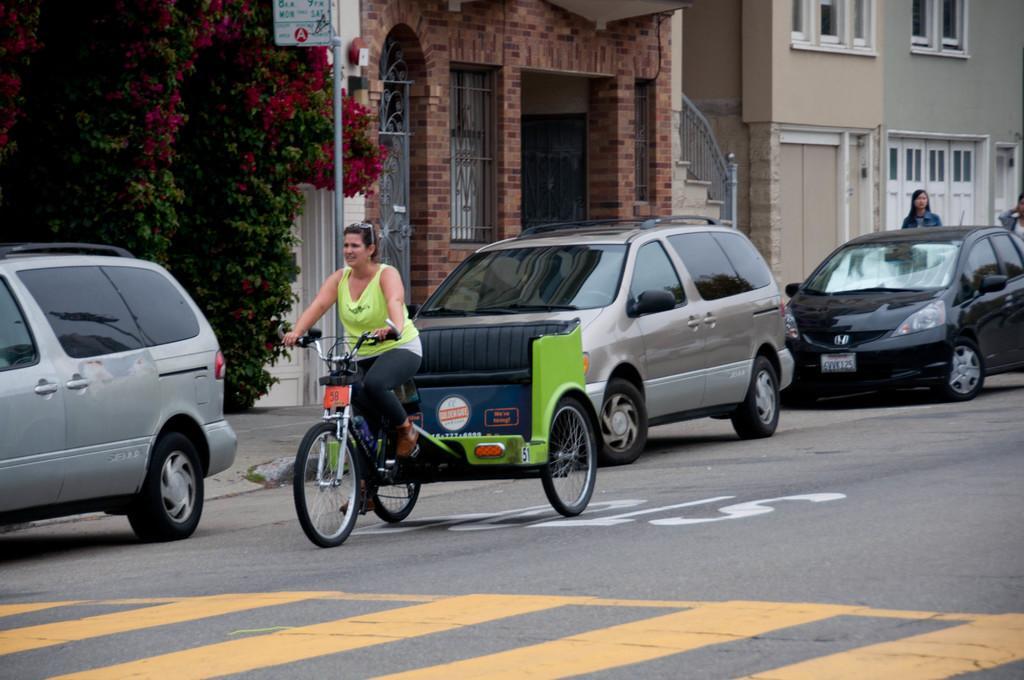Describe this image in one or two sentences. In this image woman is cycling on the road. Behind her there are cars. At the background there are buildings, trees. 